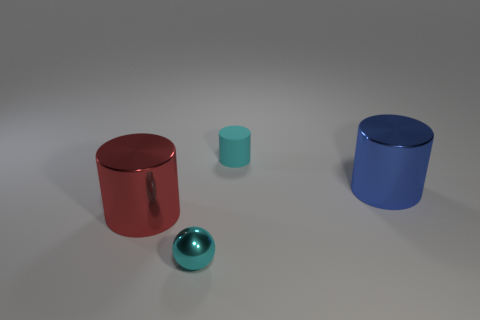Add 1 small cyan objects. How many objects exist? 5 Subtract all spheres. How many objects are left? 3 Subtract 1 cyan spheres. How many objects are left? 3 Subtract all big shiny things. Subtract all big shiny cylinders. How many objects are left? 0 Add 3 blue metallic cylinders. How many blue metallic cylinders are left? 4 Add 1 blue shiny cylinders. How many blue shiny cylinders exist? 2 